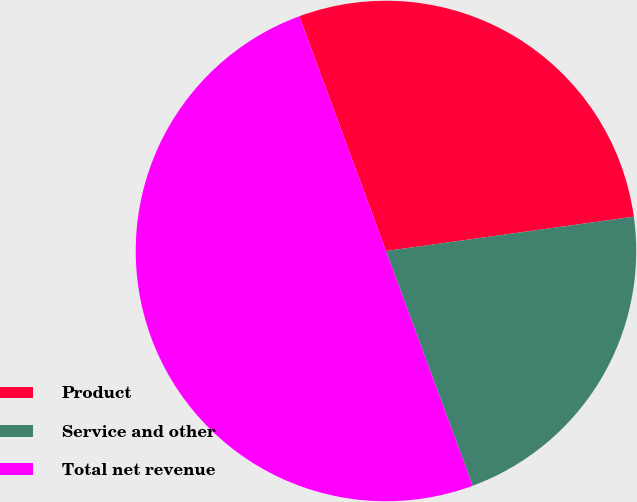Convert chart to OTSL. <chart><loc_0><loc_0><loc_500><loc_500><pie_chart><fcel>Product<fcel>Service and other<fcel>Total net revenue<nl><fcel>28.44%<fcel>21.56%<fcel>50.0%<nl></chart> 